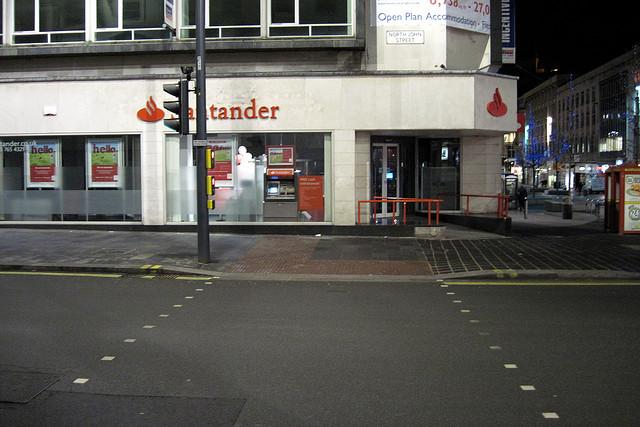What color is the road?
Short answer required. Black. What is the word on the building?
Quick response, please. Tender. Is there a crosswalk in this photo?
Keep it brief. Yes. 